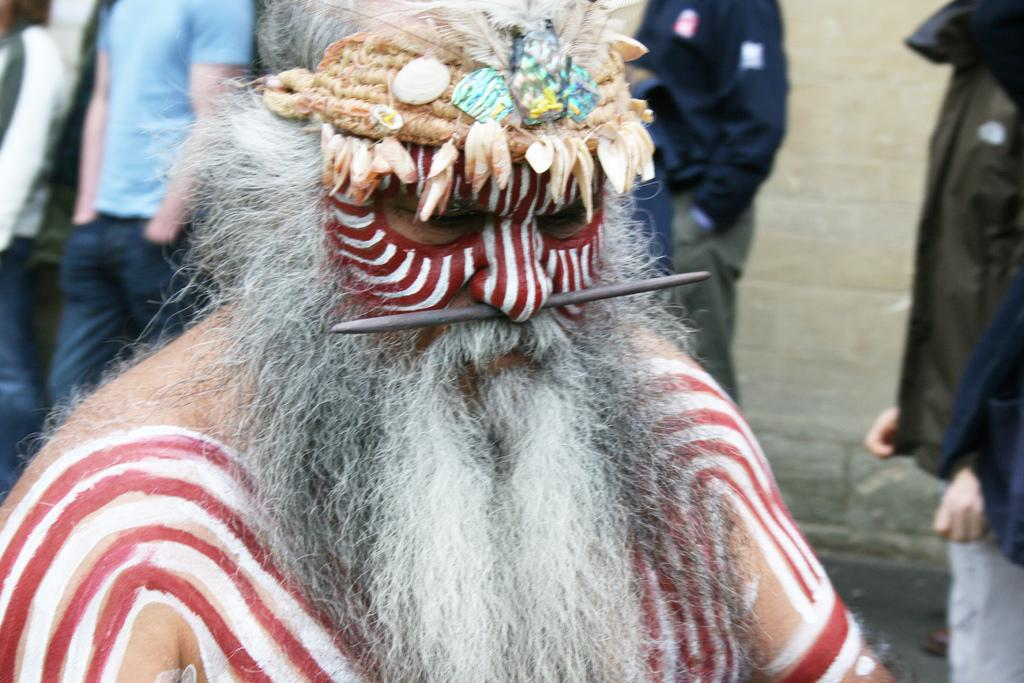What is the main subject of the image? There is a man in the image. What is on the man's face? An iron stick is on the man's face. What can be seen in the background of the image? There are people and a wall in the background of the image. What type of creature is buzzing around the man's head in the image? There is no creature buzzing around the man's head in the image. How many bees can be seen flying near the man in the image? There are no bees present in the image. 